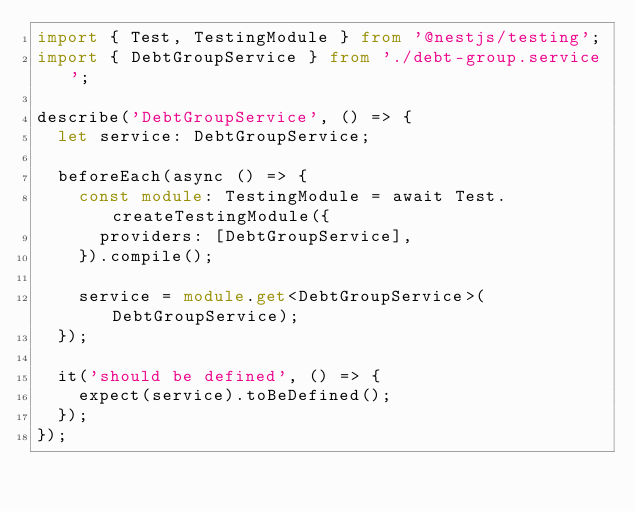Convert code to text. <code><loc_0><loc_0><loc_500><loc_500><_TypeScript_>import { Test, TestingModule } from '@nestjs/testing';
import { DebtGroupService } from './debt-group.service';

describe('DebtGroupService', () => {
  let service: DebtGroupService;

  beforeEach(async () => {
    const module: TestingModule = await Test.createTestingModule({
      providers: [DebtGroupService],
    }).compile();

    service = module.get<DebtGroupService>(DebtGroupService);
  });

  it('should be defined', () => {
    expect(service).toBeDefined();
  });
});
</code> 